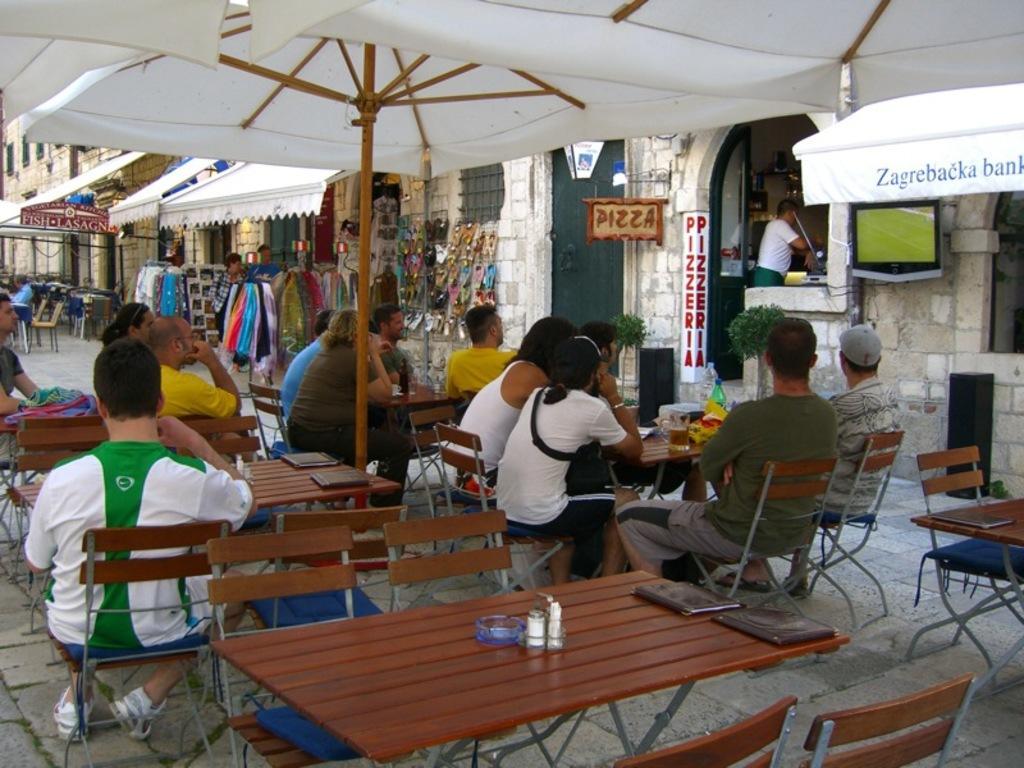Please provide a concise description of this image. In the image we can see there are people who are sitting on chair. 